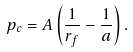<formula> <loc_0><loc_0><loc_500><loc_500>p _ { c } = A \left ( \frac { 1 } { r _ { f } } - \frac { 1 } { a } \right ) .</formula> 